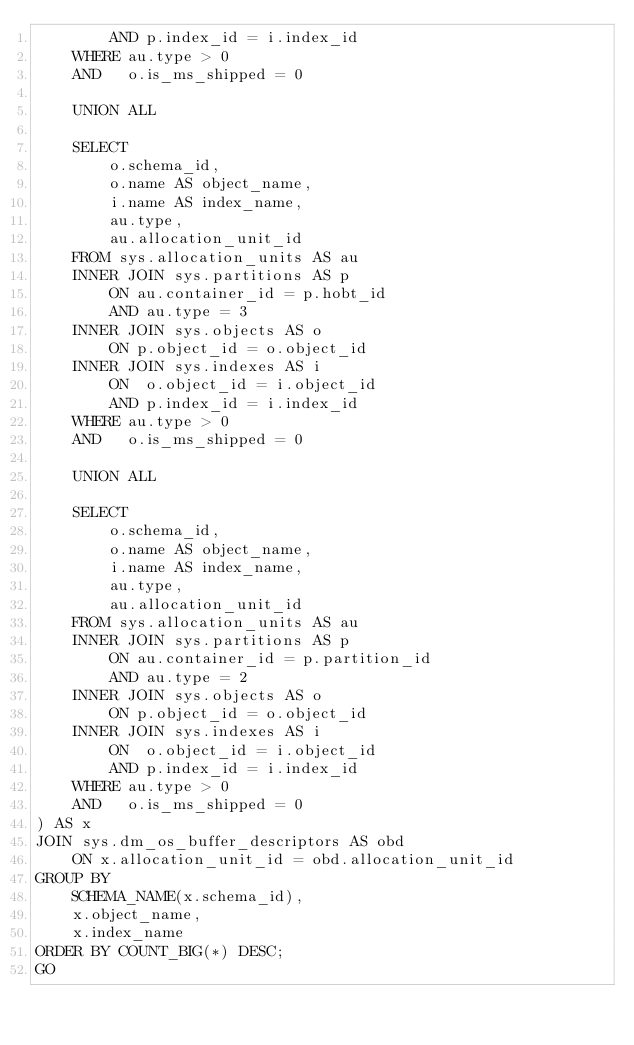<code> <loc_0><loc_0><loc_500><loc_500><_SQL_>        AND p.index_id = i.index_id
    WHERE au.type > 0
    AND   o.is_ms_shipped = 0
    
    UNION ALL
    
    SELECT       
        o.schema_id,
        o.name AS object_name,
        i.name AS index_name,
        au.type,
        au.allocation_unit_id 
    FROM sys.allocation_units AS au
    INNER JOIN sys.partitions AS p
        ON au.container_id = p.hobt_id 
        AND au.type = 3
    INNER JOIN sys.objects AS o
        ON p.object_id = o.object_id
    INNER JOIN sys.indexes AS i
        ON  o.object_id = i.object_id
        AND p.index_id = i.index_id
    WHERE au.type > 0
    AND   o.is_ms_shipped = 0
    
    UNION ALL
    
    SELECT       
        o.schema_id,
        o.name AS object_name,
        i.name AS index_name,
        au.type,
        au.allocation_unit_id 
    FROM sys.allocation_units AS au
    INNER JOIN sys.partitions AS p
        ON au.container_id = p.partition_id 
        AND au.type = 2
    INNER JOIN sys.objects AS o
        ON p.object_id = o.object_id
    INNER JOIN sys.indexes AS i
        ON  o.object_id = i.object_id
        AND p.index_id = i.index_id
    WHERE au.type > 0
    AND   o.is_ms_shipped = 0
) AS x
JOIN sys.dm_os_buffer_descriptors AS obd
    ON x.allocation_unit_id = obd.allocation_unit_id
GROUP BY 
    SCHEMA_NAME(x.schema_id), 
    x.object_name, 
    x.index_name
ORDER BY COUNT_BIG(*) DESC;
GO

</code> 